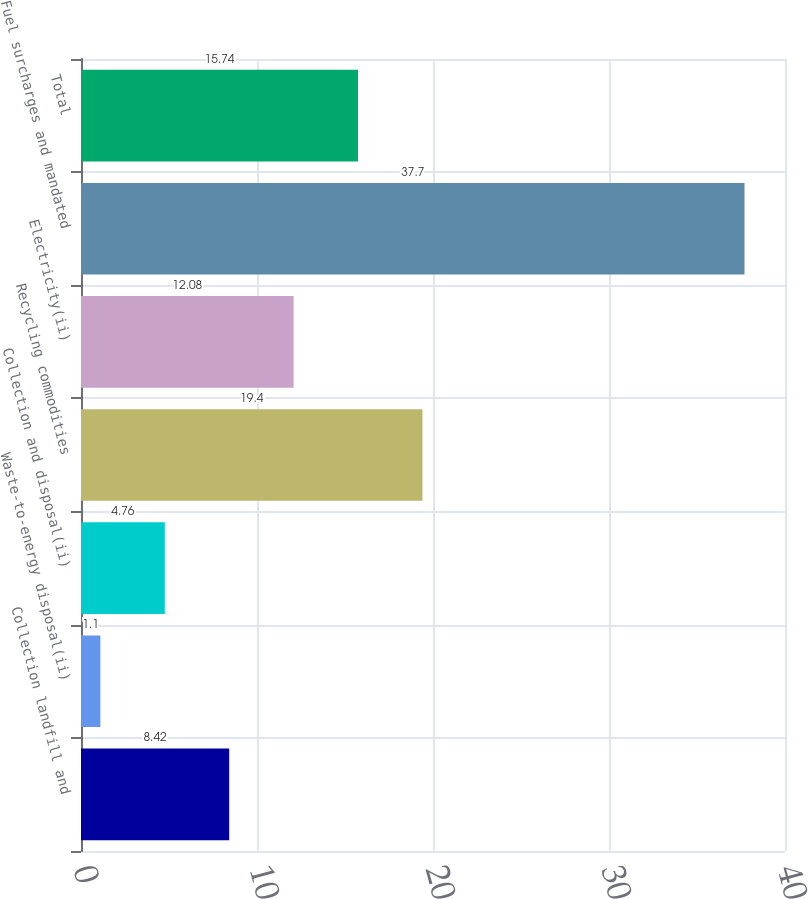<chart> <loc_0><loc_0><loc_500><loc_500><bar_chart><fcel>Collection landfill and<fcel>Waste-to-energy disposal(ii)<fcel>Collection and disposal(ii)<fcel>Recycling commodities<fcel>Electricity(ii)<fcel>Fuel surcharges and mandated<fcel>Total<nl><fcel>8.42<fcel>1.1<fcel>4.76<fcel>19.4<fcel>12.08<fcel>37.7<fcel>15.74<nl></chart> 